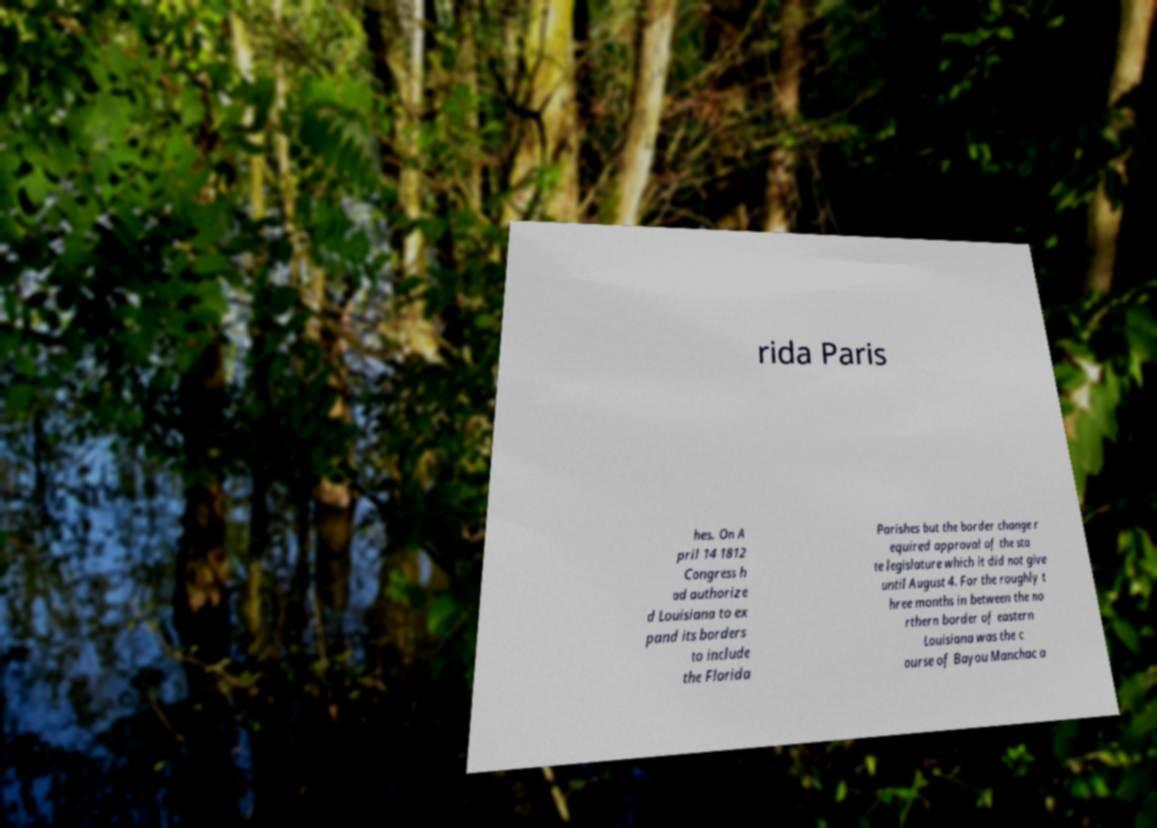Please read and relay the text visible in this image. What does it say? rida Paris hes. On A pril 14 1812 Congress h ad authorize d Louisiana to ex pand its borders to include the Florida Parishes but the border change r equired approval of the sta te legislature which it did not give until August 4. For the roughly t hree months in between the no rthern border of eastern Louisiana was the c ourse of Bayou Manchac a 